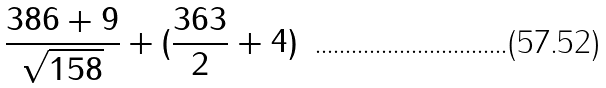<formula> <loc_0><loc_0><loc_500><loc_500>\frac { 3 8 6 + 9 } { \sqrt { 1 5 8 } } + ( \frac { 3 6 3 } { 2 } + 4 )</formula> 